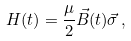Convert formula to latex. <formula><loc_0><loc_0><loc_500><loc_500>H ( t ) = \frac { \mu } { 2 } \vec { B } ( t ) \vec { \sigma } \, ,</formula> 